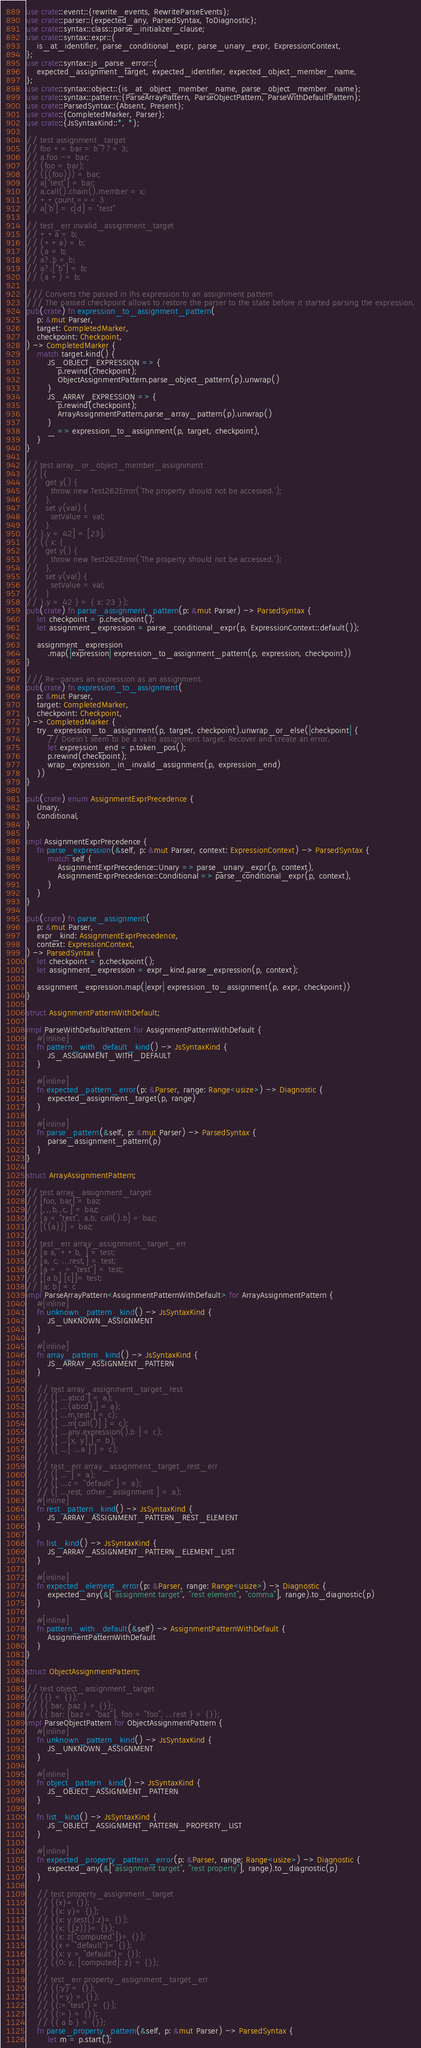Convert code to text. <code><loc_0><loc_0><loc_500><loc_500><_Rust_>use crate::event::{rewrite_events, RewriteParseEvents};
use crate::parser::{expected_any, ParsedSyntax, ToDiagnostic};
use crate::syntax::class::parse_initializer_clause;
use crate::syntax::expr::{
    is_at_identifier, parse_conditional_expr, parse_unary_expr, ExpressionContext,
};
use crate::syntax::js_parse_error::{
    expected_assignment_target, expected_identifier, expected_object_member_name,
};
use crate::syntax::object::{is_at_object_member_name, parse_object_member_name};
use crate::syntax::pattern::{ParseArrayPattern, ParseObjectPattern, ParseWithDefaultPattern};
use crate::ParsedSyntax::{Absent, Present};
use crate::{CompletedMarker, Parser};
use crate::{JsSyntaxKind::*, *};

// test assignment_target
// foo += bar = b ??= 3;
// a.foo -= bar;
// (foo = bar);
// (((foo))) = bar;
// a["test"] = bar;
// a.call().chain().member = x;
// ++count === 3
// a['b'] = c[d] = "test"

// test_err invalid_assignment_target
// ++a = b;
// (++a) = b;
// (a = b;
// a?.b = b;
// a?.["b"] = b;
// (a +) = b;

/// Converts the passed in lhs expression to an assignment pattern
/// The passed checkpoint allows to restore the parser to the state before it started parsing the expression.
pub(crate) fn expression_to_assignment_pattern(
    p: &mut Parser,
    target: CompletedMarker,
    checkpoint: Checkpoint,
) -> CompletedMarker {
    match target.kind() {
        JS_OBJECT_EXPRESSION => {
            p.rewind(checkpoint);
            ObjectAssignmentPattern.parse_object_pattern(p).unwrap()
        }
        JS_ARRAY_EXPRESSION => {
            p.rewind(checkpoint);
            ArrayAssignmentPattern.parse_array_pattern(p).unwrap()
        }
        _ => expression_to_assignment(p, target, checkpoint),
    }
}

// test array_or_object_member_assignment
// [{
//   get y() {
//     throw new Test262Error('The property should not be accessed.');
//   },
//   set y(val) {
//     setValue = val;
//   }
// }.y = 42] = [23];
// ({ x: {
//   get y() {
//     throw new Test262Error('The property should not be accessed.');
//   },
//   set y(val) {
//     setValue = val;
//   }
// }.y = 42 } = { x: 23 });
pub(crate) fn parse_assignment_pattern(p: &mut Parser) -> ParsedSyntax {
    let checkpoint = p.checkpoint();
    let assignment_expression = parse_conditional_expr(p, ExpressionContext::default());

    assignment_expression
        .map(|expression| expression_to_assignment_pattern(p, expression, checkpoint))
}

/// Re-parses an expression as an assignment.
pub(crate) fn expression_to_assignment(
    p: &mut Parser,
    target: CompletedMarker,
    checkpoint: Checkpoint,
) -> CompletedMarker {
    try_expression_to_assignment(p, target, checkpoint).unwrap_or_else(|checkpoint| {
        // Doesn't seem to be a valid assignment target. Recover and create an error.
        let expression_end = p.token_pos();
        p.rewind(checkpoint);
        wrap_expression_in_invalid_assignment(p, expression_end)
    })
}

pub(crate) enum AssignmentExprPrecedence {
    Unary,
    Conditional,
}

impl AssignmentExprPrecedence {
    fn parse_expression(&self, p: &mut Parser, context: ExpressionContext) -> ParsedSyntax {
        match self {
            AssignmentExprPrecedence::Unary => parse_unary_expr(p, context),
            AssignmentExprPrecedence::Conditional => parse_conditional_expr(p, context),
        }
    }
}

pub(crate) fn parse_assignment(
    p: &mut Parser,
    expr_kind: AssignmentExprPrecedence,
    context: ExpressionContext,
) -> ParsedSyntax {
    let checkpoint = p.checkpoint();
    let assignment_expression = expr_kind.parse_expression(p, context);

    assignment_expression.map(|expr| expression_to_assignment(p, expr, checkpoint))
}

struct AssignmentPatternWithDefault;

impl ParseWithDefaultPattern for AssignmentPatternWithDefault {
    #[inline]
    fn pattern_with_default_kind() -> JsSyntaxKind {
        JS_ASSIGNMENT_WITH_DEFAULT
    }

    #[inline]
    fn expected_pattern_error(p: &Parser, range: Range<usize>) -> Diagnostic {
        expected_assignment_target(p, range)
    }

    #[inline]
    fn parse_pattern(&self, p: &mut Parser) -> ParsedSyntax {
        parse_assignment_pattern(p)
    }
}

struct ArrayAssignmentPattern;

// test array_assignment_target
// [foo, bar] = baz;
// [,,,b,,c,] = baz;
// [a = "test", a.b, call().b] = baz;
// [((a))] = baz;
//
// test_err array_assignment_target_err
// [a a, ++b, ] = test;
// [a, c, ...rest,] = test;
// [a = , = "test"] = test;
// [[a b] [c]]= test;
// [a: b] = c
impl ParseArrayPattern<AssignmentPatternWithDefault> for ArrayAssignmentPattern {
    #[inline]
    fn unknown_pattern_kind() -> JsSyntaxKind {
        JS_UNKNOWN_ASSIGNMENT
    }

    #[inline]
    fn array_pattern_kind() -> JsSyntaxKind {
        JS_ARRAY_ASSIGNMENT_PATTERN
    }

    // test array_assignment_target_rest
    // ([ ...abcd ] = a);
    // ([ ...(abcd) ] = a);
    // ([ ...m.test ] = c);
    // ([ ...m[call()] ] = c);
    // ([ ...any.expression().b ] = c);
    // ([ ...[x, y] ] = b);
    // ([ ...[ ...a ] ] = c);
    //
    // test_err array_assignment_target_rest_err
    // ([ ... ] = a);
    // ([ ...c = "default" ] = a);
    // ([ ...rest, other_assignment ] = a);
    #[inline]
    fn rest_pattern_kind() -> JsSyntaxKind {
        JS_ARRAY_ASSIGNMENT_PATTERN_REST_ELEMENT
    }

    fn list_kind() -> JsSyntaxKind {
        JS_ARRAY_ASSIGNMENT_PATTERN_ELEMENT_LIST
    }

    #[inline]
    fn expected_element_error(p: &Parser, range: Range<usize>) -> Diagnostic {
        expected_any(&["assignment target", "rest element", "comma"], range).to_diagnostic(p)
    }

    #[inline]
    fn pattern_with_default(&self) -> AssignmentPatternWithDefault {
        AssignmentPatternWithDefault
    }
}

struct ObjectAssignmentPattern;

// test object_assignment_target
// ({} = {});
// ({ bar, baz } = {});
// ({ bar: [baz = "baz"], foo = "foo", ...rest } = {});
impl ParseObjectPattern for ObjectAssignmentPattern {
    #[inline]
    fn unknown_pattern_kind() -> JsSyntaxKind {
        JS_UNKNOWN_ASSIGNMENT
    }

    #[inline]
    fn object_pattern_kind() -> JsSyntaxKind {
        JS_OBJECT_ASSIGNMENT_PATTERN
    }

    fn list_kind() -> JsSyntaxKind {
        JS_OBJECT_ASSIGNMENT_PATTERN_PROPERTY_LIST
    }

    #[inline]
    fn expected_property_pattern_error(p: &Parser, range: Range<usize>) -> Diagnostic {
        expected_any(&["assignment target", "rest property"], range).to_diagnostic(p)
    }

    // test property_assignment_target
    // ({x}= {});
    // ({x: y}= {});
    // ({x: y.test().z}= {});
    // ({x: ((z))}= {});
    // ({x: z["computed"]}= {});
    // ({x = "default"}= {});
    // ({x: y = "default"}= {});
    // ({0: y, [computed]: z} = {});
    //
    // test_err property_assignment_target_err
    // ({:y} = {});
    // ({=y} = {});
    // ({:="test"} = {});
    // ({:=} = {});
    // ({ a b } = {});
    fn parse_property_pattern(&self, p: &mut Parser) -> ParsedSyntax {
        let m = p.start();
</code> 